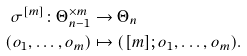Convert formula to latex. <formula><loc_0><loc_0><loc_500><loc_500>\sigma ^ { [ m ] } \colon \Theta _ { n - 1 } ^ { \times m } & \to \Theta _ { n } \\ ( o _ { 1 } , \dots , o _ { m } ) & \mapsto ( { [ m ] } ; o _ { 1 } , \dots , o _ { m } ) .</formula> 